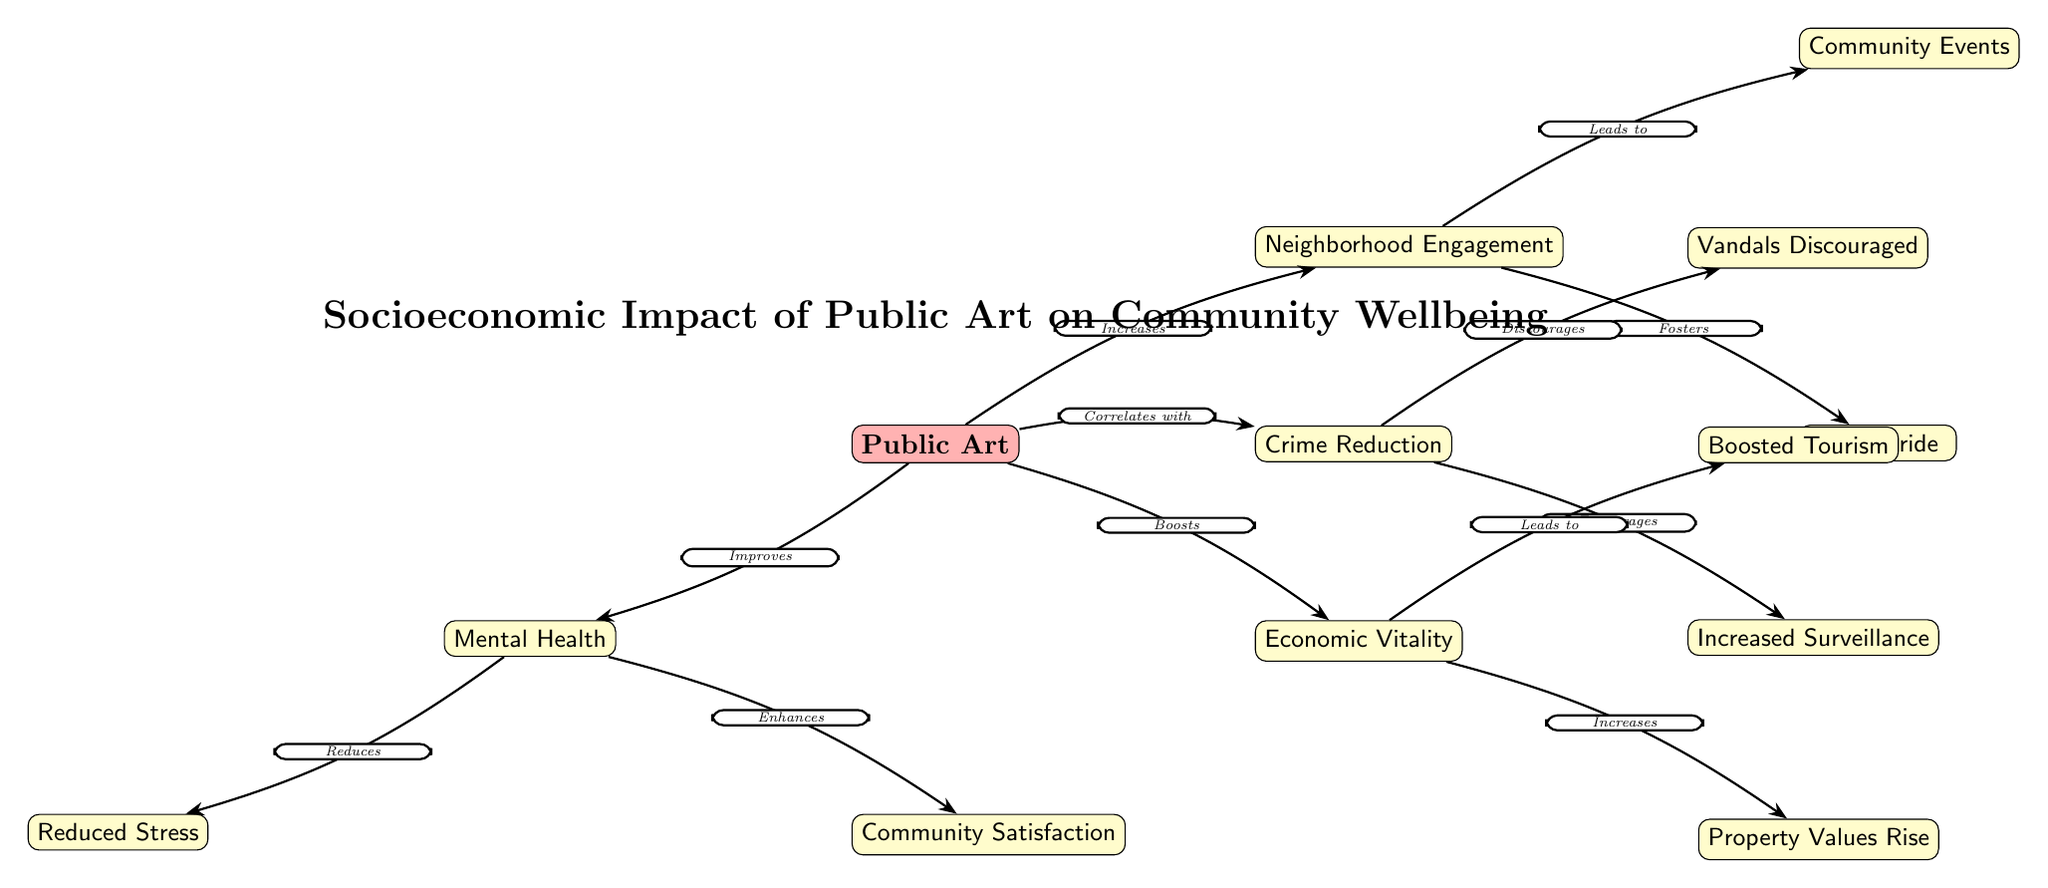What is the central concept represented in the diagram? The diagram centers around "Public Art," which is the starting node that connects to various socioeconomic impacts and community wellbeing aspects.
Answer: Public Art How many primary impacts of public art are illustrated in the diagram? There are four primary impacts illustrated, which include neighborhood engagement, crime reduction, economic vitality, and mental health.
Answer: Four What does neighborhood engagement correlate with? Neighborhood engagement correlates with crime reduction as it is shown as an edge from public art to neighborhood engagement leading to crime reduction as a subsequent effect.
Answer: Crime Reduction What is the outcome of neighborhood engagement that encourages community pride? The diagram indicates that from neighborhood engagement, there are outcomes like community events and local pride, which contribute to a sense of pride in the community.
Answer: Local Pride How does public art impact mental health according to the diagram? Public art improves mental health, which, in turn, reduces stress and enhances community satisfaction as displayed in the connected nodes.
Answer: Improves What kind of events does neighborhood engagement lead to? Neighborhood engagement leads to community events, showcasing the direct relationship between engaging the community and organizing events for that community.
Answer: Community Events What effect does economic vitality have according to the diagram? Economic vitality leads to boosted tourism and increases in property values as seen from the connections flowing out from the economic vitality node.
Answer: Boosted Tourism What does crime reduction encourage in the community? Crime reduction encourages increased surveillance, indicating a proactive measure in response to reduced crime levels influenced by public art.
Answer: Increased Surveillance Which metric is associated with improved community satisfaction? Improved community satisfaction is associated with better mental health outcomes as shown in the diagram, which is linked to the improvements stemming from public art.
Answer: Mental Health 